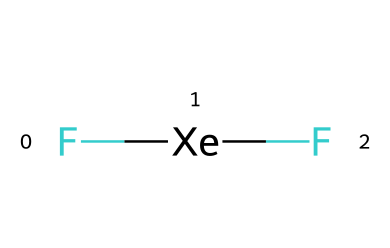what is the name of this chemical? The chemical is composed of xenon and fluorine atoms. From the provided SMILES representation, we can determine the components as it indicates two fluorine (F) atoms and one xenon (Xe) atom. Therefore, the name of the chemical is obtained from their combination.
Answer: xenon difluoride how many atoms are present in the molecule? The structure includes one xenon atom and two fluorine atoms, which can be counted from the SMILES representation. Adding these gives a total of three atoms.
Answer: three how many bonds are present in this molecule? The SMILES notation shows that the two fluorine atoms are bonded to a single xenon atom. Since each of the fluorine atoms is bonded to the xenon, and there are two fluorine atoms, there are two bonds total.
Answer: two what type of chemical is xenon difluoride? Xenon difluoride falls under the category of noble gas compounds, as it involves xenon, a noble gas, combined with fluorine, a halogen. This unique bond formation is characteristic of noble gas chemistry.
Answer: noble gas compound why can xenon difluoride be used in medical imaging? Xenon difluoride possesses properties that allow it to serve in imaging applications due to its stability and reactivity with certain contrast agents, making it useful in molecular imaging processes. Its noble gas nature contributes to its low reactivity under normal conditions, enhancing its utility.
Answer: imaging applications is xenon difluoride polar or non-polar? Considering the electronegativity difference between xenon and fluorine, the presence of fluorine creates a dipole with a permanent molecular geometry, leading to a polar molecule. Thus, the arrangement of atoms results in a net dipole moment.
Answer: polar 